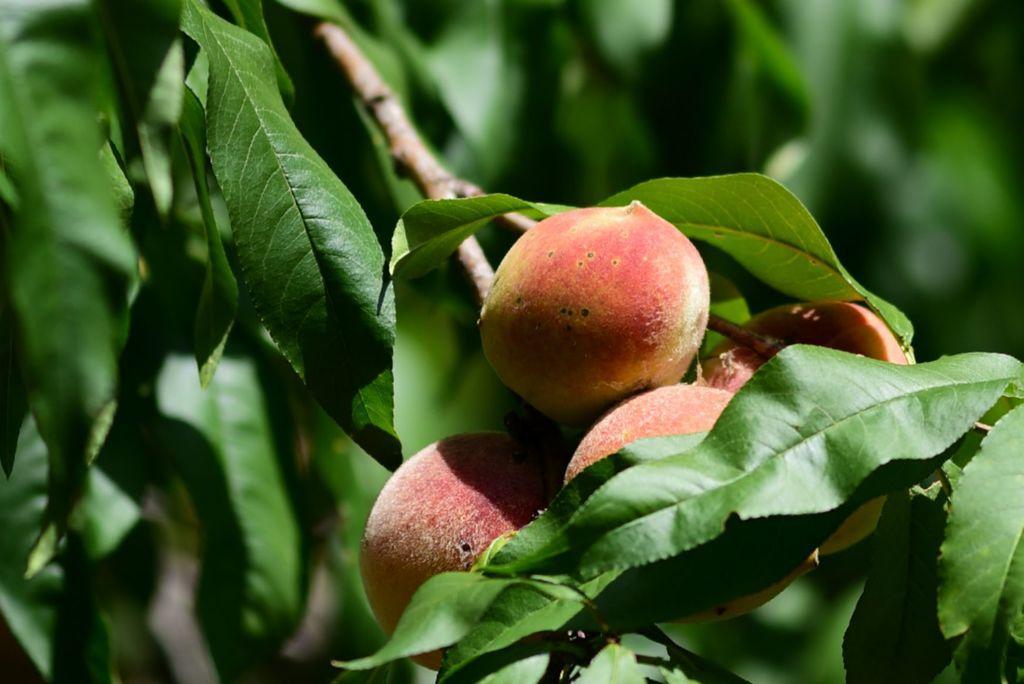Can you describe this image briefly? In this image there is a plant to which there are fruits and green leaves beside it. 